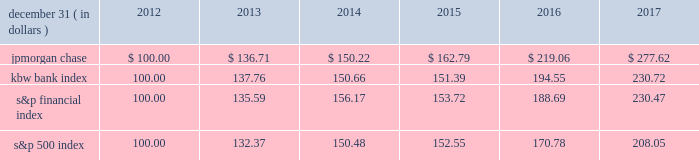Jpmorgan chase & co./2017 annual report 39 five-year stock performance the table and graph compare the five-year cumulative total return for jpmorgan chase & co .
( 201cjpmorgan chase 201d or the 201cfirm 201d ) common stock with the cumulative return of the s&p 500 index , the kbw bank index and the s&p financial index .
The s&p 500 index is a commonly referenced equity benchmark in the united states of america ( 201cu.s . 201d ) , consisting of leading companies from different economic sectors .
The kbw bank index seeks to reflect the performance of banks and thrifts that are publicly traded in the u.s .
And is composed of leading national money center and regional banks and thrifts .
The s&p financial index is an index of financial companies , all of which are components of the s&p 500 .
The firm is a component of all three industry indices .
The table and graph assume simultaneous investments of $ 100 on december 31 , 2012 , in jpmorgan chase common stock and in each of the above indices .
The comparison assumes that all dividends are reinvested .
December 31 , ( in dollars ) 2012 2013 2014 2015 2016 2017 .
December 31 , ( in dollars ) 201720162015201420132012 .
Based on the review of the simultaneous investments of the jpmorgan chase common stock in various indices what was the ratio of the performance of the kbw bank index to the s&p financial index? 
Computations: (151.39 / 153.72)
Answer: 0.98484. 